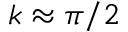Convert formula to latex. <formula><loc_0><loc_0><loc_500><loc_500>k \approx \pi / 2</formula> 